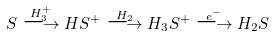Convert formula to latex. <formula><loc_0><loc_0><loc_500><loc_500>S \stackrel { H _ { 3 } ^ { + } } { \longrightarrow } H S ^ { + } \stackrel { H _ { 2 } } { \longrightarrow } H _ { 3 } S ^ { + } \stackrel { e ^ { - } } { \longrightarrow } H _ { 2 } S</formula> 